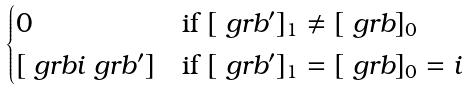Convert formula to latex. <formula><loc_0><loc_0><loc_500><loc_500>\begin{cases} 0 & \text {if } [ \ g r b ^ { \prime } ] _ { 1 } \neq [ \ g r b ] _ { 0 } \\ { [ \ g r b i \ g r b ^ { \prime } ] } & \text {if } [ \ g r b ^ { \prime } ] _ { 1 } = [ \ g r b ] _ { 0 } = i \end{cases}</formula> 